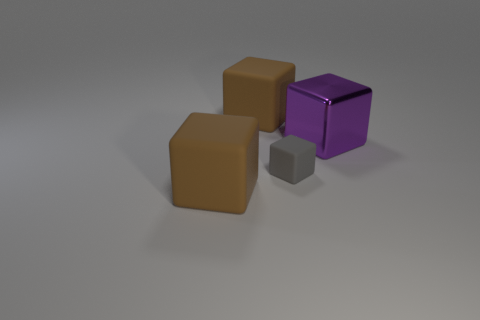Subtract all matte blocks. How many blocks are left? 1 Subtract all brown blocks. How many blocks are left? 2 Add 1 tiny gray cubes. How many objects exist? 5 Add 2 tiny matte blocks. How many tiny matte blocks exist? 3 Subtract 0 gray spheres. How many objects are left? 4 Subtract all blue cubes. Subtract all purple spheres. How many cubes are left? 4 Subtract all purple spheres. How many cyan blocks are left? 0 Subtract all large objects. Subtract all small rubber cubes. How many objects are left? 0 Add 1 purple objects. How many purple objects are left? 2 